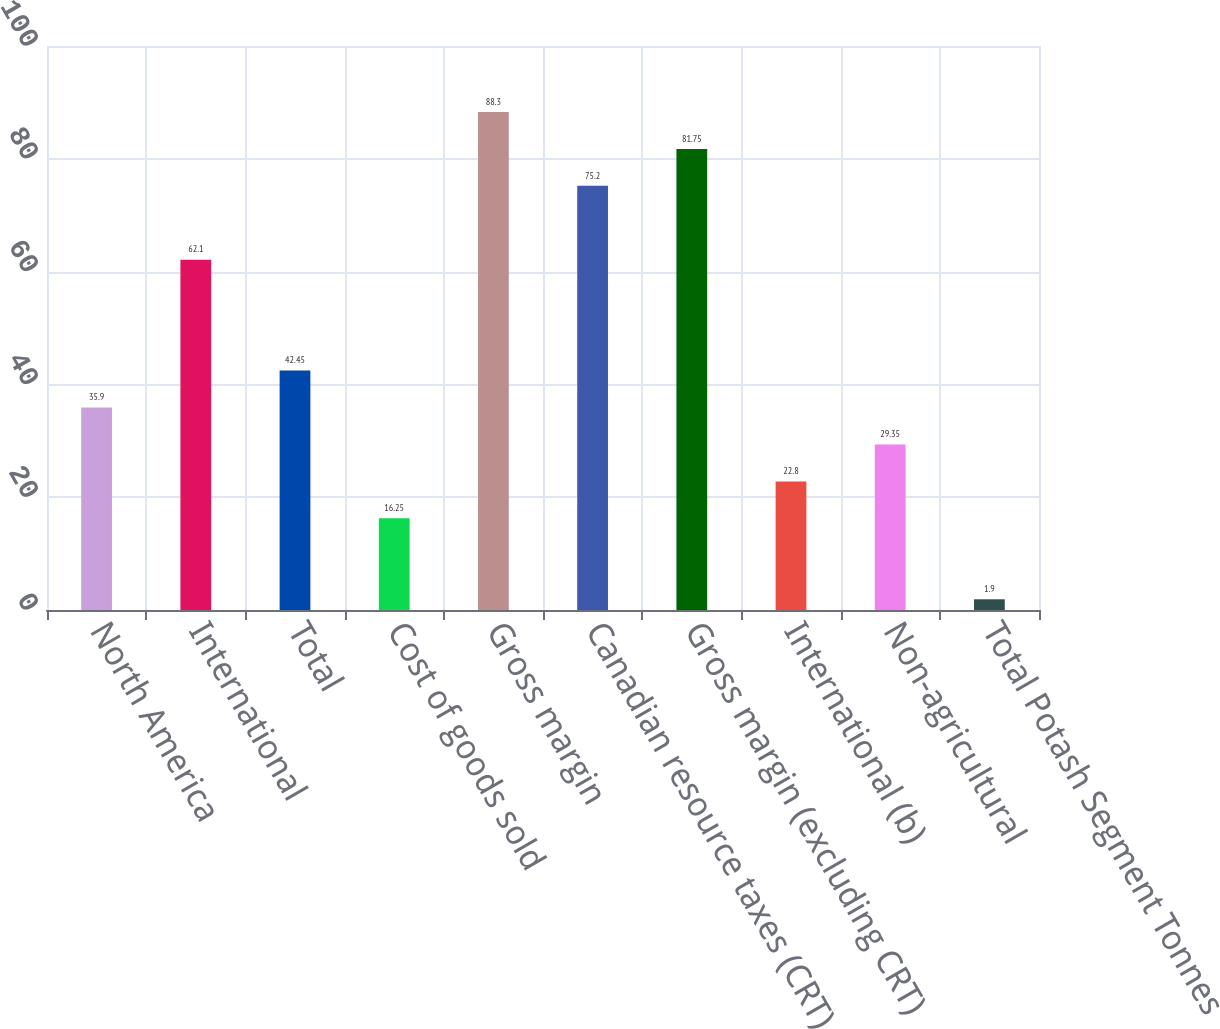<chart> <loc_0><loc_0><loc_500><loc_500><bar_chart><fcel>North America<fcel>International<fcel>Total<fcel>Cost of goods sold<fcel>Gross margin<fcel>Canadian resource taxes (CRT)<fcel>Gross margin (excluding CRT)<fcel>International (b)<fcel>Non-agricultural<fcel>Total Potash Segment Tonnes<nl><fcel>35.9<fcel>62.1<fcel>42.45<fcel>16.25<fcel>88.3<fcel>75.2<fcel>81.75<fcel>22.8<fcel>29.35<fcel>1.9<nl></chart> 